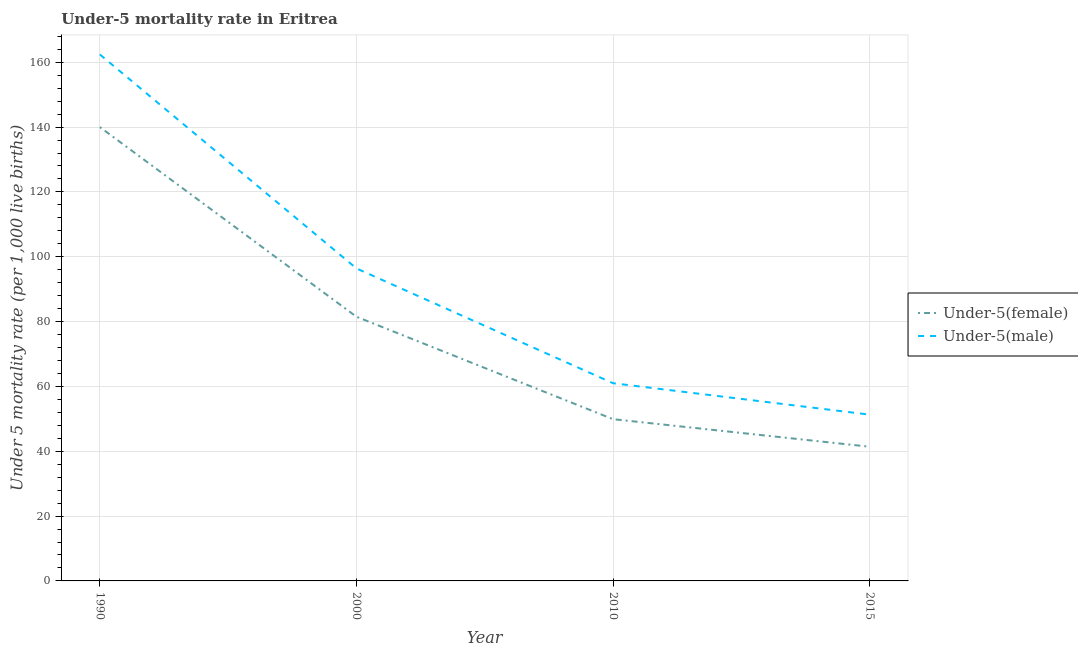How many different coloured lines are there?
Your answer should be compact. 2. Does the line corresponding to under-5 female mortality rate intersect with the line corresponding to under-5 male mortality rate?
Your answer should be compact. No. Is the number of lines equal to the number of legend labels?
Make the answer very short. Yes. Across all years, what is the maximum under-5 male mortality rate?
Your answer should be very brief. 162.4. Across all years, what is the minimum under-5 male mortality rate?
Your response must be concise. 51.3. In which year was the under-5 male mortality rate maximum?
Offer a very short reply. 1990. In which year was the under-5 male mortality rate minimum?
Keep it short and to the point. 2015. What is the total under-5 male mortality rate in the graph?
Your response must be concise. 371.1. What is the difference between the under-5 male mortality rate in 2010 and that in 2015?
Provide a short and direct response. 9.7. What is the difference between the under-5 male mortality rate in 2010 and the under-5 female mortality rate in 1990?
Give a very brief answer. -79. What is the average under-5 male mortality rate per year?
Offer a very short reply. 92.78. In the year 2010, what is the difference between the under-5 male mortality rate and under-5 female mortality rate?
Offer a terse response. 11.1. In how many years, is the under-5 female mortality rate greater than 140?
Your response must be concise. 0. What is the ratio of the under-5 female mortality rate in 2000 to that in 2015?
Ensure brevity in your answer.  1.97. Is the under-5 female mortality rate in 2000 less than that in 2015?
Offer a very short reply. No. What is the difference between the highest and the second highest under-5 female mortality rate?
Keep it short and to the point. 58.5. What is the difference between the highest and the lowest under-5 male mortality rate?
Keep it short and to the point. 111.1. Is the sum of the under-5 male mortality rate in 2000 and 2010 greater than the maximum under-5 female mortality rate across all years?
Make the answer very short. Yes. Does the under-5 female mortality rate monotonically increase over the years?
Ensure brevity in your answer.  No. Is the under-5 male mortality rate strictly greater than the under-5 female mortality rate over the years?
Provide a short and direct response. Yes. Is the under-5 female mortality rate strictly less than the under-5 male mortality rate over the years?
Make the answer very short. Yes. What is the difference between two consecutive major ticks on the Y-axis?
Provide a short and direct response. 20. Does the graph contain any zero values?
Offer a very short reply. No. How many legend labels are there?
Make the answer very short. 2. How are the legend labels stacked?
Your answer should be very brief. Vertical. What is the title of the graph?
Offer a terse response. Under-5 mortality rate in Eritrea. What is the label or title of the X-axis?
Offer a terse response. Year. What is the label or title of the Y-axis?
Offer a very short reply. Under 5 mortality rate (per 1,0 live births). What is the Under 5 mortality rate (per 1,000 live births) of Under-5(female) in 1990?
Provide a short and direct response. 140. What is the Under 5 mortality rate (per 1,000 live births) in Under-5(male) in 1990?
Make the answer very short. 162.4. What is the Under 5 mortality rate (per 1,000 live births) in Under-5(female) in 2000?
Ensure brevity in your answer.  81.5. What is the Under 5 mortality rate (per 1,000 live births) of Under-5(male) in 2000?
Keep it short and to the point. 96.4. What is the Under 5 mortality rate (per 1,000 live births) in Under-5(female) in 2010?
Keep it short and to the point. 49.9. What is the Under 5 mortality rate (per 1,000 live births) in Under-5(female) in 2015?
Offer a very short reply. 41.4. What is the Under 5 mortality rate (per 1,000 live births) of Under-5(male) in 2015?
Offer a very short reply. 51.3. Across all years, what is the maximum Under 5 mortality rate (per 1,000 live births) of Under-5(female)?
Give a very brief answer. 140. Across all years, what is the maximum Under 5 mortality rate (per 1,000 live births) in Under-5(male)?
Give a very brief answer. 162.4. Across all years, what is the minimum Under 5 mortality rate (per 1,000 live births) of Under-5(female)?
Your answer should be very brief. 41.4. Across all years, what is the minimum Under 5 mortality rate (per 1,000 live births) of Under-5(male)?
Your response must be concise. 51.3. What is the total Under 5 mortality rate (per 1,000 live births) in Under-5(female) in the graph?
Your response must be concise. 312.8. What is the total Under 5 mortality rate (per 1,000 live births) of Under-5(male) in the graph?
Provide a short and direct response. 371.1. What is the difference between the Under 5 mortality rate (per 1,000 live births) in Under-5(female) in 1990 and that in 2000?
Keep it short and to the point. 58.5. What is the difference between the Under 5 mortality rate (per 1,000 live births) in Under-5(male) in 1990 and that in 2000?
Offer a terse response. 66. What is the difference between the Under 5 mortality rate (per 1,000 live births) of Under-5(female) in 1990 and that in 2010?
Provide a short and direct response. 90.1. What is the difference between the Under 5 mortality rate (per 1,000 live births) of Under-5(male) in 1990 and that in 2010?
Keep it short and to the point. 101.4. What is the difference between the Under 5 mortality rate (per 1,000 live births) of Under-5(female) in 1990 and that in 2015?
Your response must be concise. 98.6. What is the difference between the Under 5 mortality rate (per 1,000 live births) of Under-5(male) in 1990 and that in 2015?
Make the answer very short. 111.1. What is the difference between the Under 5 mortality rate (per 1,000 live births) of Under-5(female) in 2000 and that in 2010?
Provide a succinct answer. 31.6. What is the difference between the Under 5 mortality rate (per 1,000 live births) of Under-5(male) in 2000 and that in 2010?
Give a very brief answer. 35.4. What is the difference between the Under 5 mortality rate (per 1,000 live births) of Under-5(female) in 2000 and that in 2015?
Make the answer very short. 40.1. What is the difference between the Under 5 mortality rate (per 1,000 live births) of Under-5(male) in 2000 and that in 2015?
Ensure brevity in your answer.  45.1. What is the difference between the Under 5 mortality rate (per 1,000 live births) of Under-5(female) in 2010 and that in 2015?
Your answer should be compact. 8.5. What is the difference between the Under 5 mortality rate (per 1,000 live births) of Under-5(male) in 2010 and that in 2015?
Your answer should be very brief. 9.7. What is the difference between the Under 5 mortality rate (per 1,000 live births) of Under-5(female) in 1990 and the Under 5 mortality rate (per 1,000 live births) of Under-5(male) in 2000?
Ensure brevity in your answer.  43.6. What is the difference between the Under 5 mortality rate (per 1,000 live births) in Under-5(female) in 1990 and the Under 5 mortality rate (per 1,000 live births) in Under-5(male) in 2010?
Ensure brevity in your answer.  79. What is the difference between the Under 5 mortality rate (per 1,000 live births) of Under-5(female) in 1990 and the Under 5 mortality rate (per 1,000 live births) of Under-5(male) in 2015?
Ensure brevity in your answer.  88.7. What is the difference between the Under 5 mortality rate (per 1,000 live births) of Under-5(female) in 2000 and the Under 5 mortality rate (per 1,000 live births) of Under-5(male) in 2015?
Give a very brief answer. 30.2. What is the difference between the Under 5 mortality rate (per 1,000 live births) in Under-5(female) in 2010 and the Under 5 mortality rate (per 1,000 live births) in Under-5(male) in 2015?
Keep it short and to the point. -1.4. What is the average Under 5 mortality rate (per 1,000 live births) in Under-5(female) per year?
Provide a short and direct response. 78.2. What is the average Under 5 mortality rate (per 1,000 live births) in Under-5(male) per year?
Provide a succinct answer. 92.78. In the year 1990, what is the difference between the Under 5 mortality rate (per 1,000 live births) of Under-5(female) and Under 5 mortality rate (per 1,000 live births) of Under-5(male)?
Your answer should be compact. -22.4. In the year 2000, what is the difference between the Under 5 mortality rate (per 1,000 live births) of Under-5(female) and Under 5 mortality rate (per 1,000 live births) of Under-5(male)?
Give a very brief answer. -14.9. In the year 2010, what is the difference between the Under 5 mortality rate (per 1,000 live births) in Under-5(female) and Under 5 mortality rate (per 1,000 live births) in Under-5(male)?
Give a very brief answer. -11.1. In the year 2015, what is the difference between the Under 5 mortality rate (per 1,000 live births) in Under-5(female) and Under 5 mortality rate (per 1,000 live births) in Under-5(male)?
Your answer should be compact. -9.9. What is the ratio of the Under 5 mortality rate (per 1,000 live births) of Under-5(female) in 1990 to that in 2000?
Offer a terse response. 1.72. What is the ratio of the Under 5 mortality rate (per 1,000 live births) of Under-5(male) in 1990 to that in 2000?
Your answer should be compact. 1.68. What is the ratio of the Under 5 mortality rate (per 1,000 live births) of Under-5(female) in 1990 to that in 2010?
Offer a very short reply. 2.81. What is the ratio of the Under 5 mortality rate (per 1,000 live births) in Under-5(male) in 1990 to that in 2010?
Provide a short and direct response. 2.66. What is the ratio of the Under 5 mortality rate (per 1,000 live births) in Under-5(female) in 1990 to that in 2015?
Offer a terse response. 3.38. What is the ratio of the Under 5 mortality rate (per 1,000 live births) in Under-5(male) in 1990 to that in 2015?
Your answer should be compact. 3.17. What is the ratio of the Under 5 mortality rate (per 1,000 live births) in Under-5(female) in 2000 to that in 2010?
Provide a succinct answer. 1.63. What is the ratio of the Under 5 mortality rate (per 1,000 live births) in Under-5(male) in 2000 to that in 2010?
Ensure brevity in your answer.  1.58. What is the ratio of the Under 5 mortality rate (per 1,000 live births) of Under-5(female) in 2000 to that in 2015?
Ensure brevity in your answer.  1.97. What is the ratio of the Under 5 mortality rate (per 1,000 live births) in Under-5(male) in 2000 to that in 2015?
Your answer should be compact. 1.88. What is the ratio of the Under 5 mortality rate (per 1,000 live births) in Under-5(female) in 2010 to that in 2015?
Keep it short and to the point. 1.21. What is the ratio of the Under 5 mortality rate (per 1,000 live births) of Under-5(male) in 2010 to that in 2015?
Offer a very short reply. 1.19. What is the difference between the highest and the second highest Under 5 mortality rate (per 1,000 live births) in Under-5(female)?
Your response must be concise. 58.5. What is the difference between the highest and the second highest Under 5 mortality rate (per 1,000 live births) in Under-5(male)?
Keep it short and to the point. 66. What is the difference between the highest and the lowest Under 5 mortality rate (per 1,000 live births) of Under-5(female)?
Provide a succinct answer. 98.6. What is the difference between the highest and the lowest Under 5 mortality rate (per 1,000 live births) of Under-5(male)?
Your response must be concise. 111.1. 